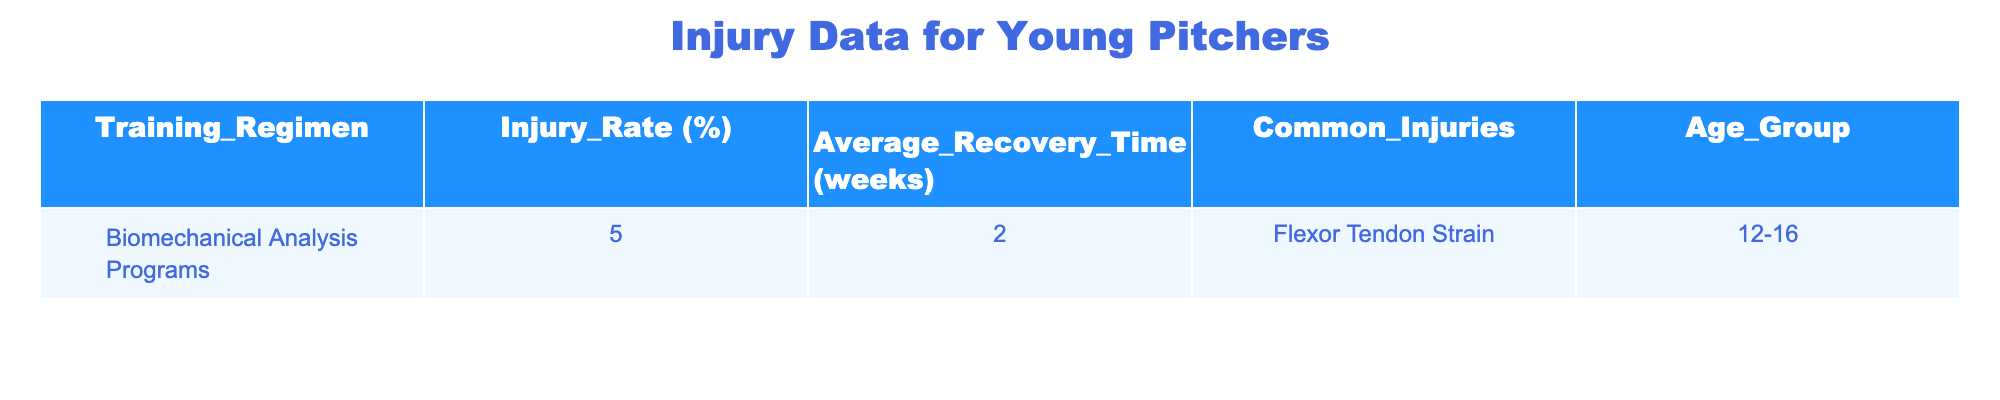What is the injury rate for young pitchers following biomechanical analysis programs? According to the table, the injury rate for young pitchers following biomechanical analysis programs is directly listed as 5%.
Answer: 5% What is the average recovery time for young pitchers with flexor tendon strain? The average recovery time specified in the table for young pitchers with flexor tendon strain is 2 weeks.
Answer: 2 weeks Are flexor tendon strains common injuries in the specified age group? Yes, the table states that flexor tendon strain is listed as a common injury for the age group of 12-16 years.
Answer: Yes What percentage of young pitchers experience injuries when following biomechanical analysis programs? The table shows that 5% of young pitchers experience injuries when following biomechanical analysis programs.
Answer: 5% Is there any training regimen in the table that has an injury rate above 10%? No, based on the provided data, there is no training regimen that has an injury rate above 10%.
Answer: No What is the total recovery time in weeks for both common injuries reported in the data? There is only one common injury listed (flexor tendon strain) with a recovery time of 2 weeks, so the total recovery time remains 2 weeks.
Answer: 2 weeks How does the injury rate for biomechanical analysis programs compare to a hypothetical regimen with a 10% injury rate? The injury rate for biomechanical analysis programs is lower; it is 5%, which is 5% less than the hypothetical 10% injury rate.
Answer: Lower At what age do the common injuries listed occur according to the table? The common injuries are reported to occur in the age group of 12-16 years.
Answer: 12-16 years 